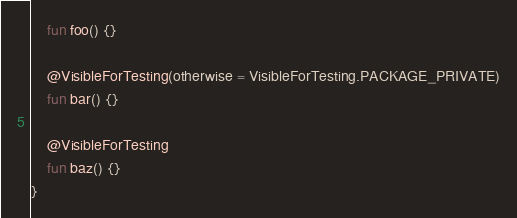Convert code to text. <code><loc_0><loc_0><loc_500><loc_500><_Kotlin_>    fun foo() {}

    @VisibleForTesting(otherwise = VisibleForTesting.PACKAGE_PRIVATE)
    fun bar() {}

    @VisibleForTesting
    fun baz() {}
}</code> 